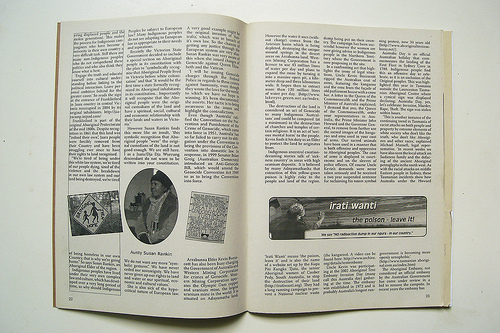<image>
Is there a illustration under the book? No. The illustration is not positioned under the book. The vertical relationship between these objects is different. 